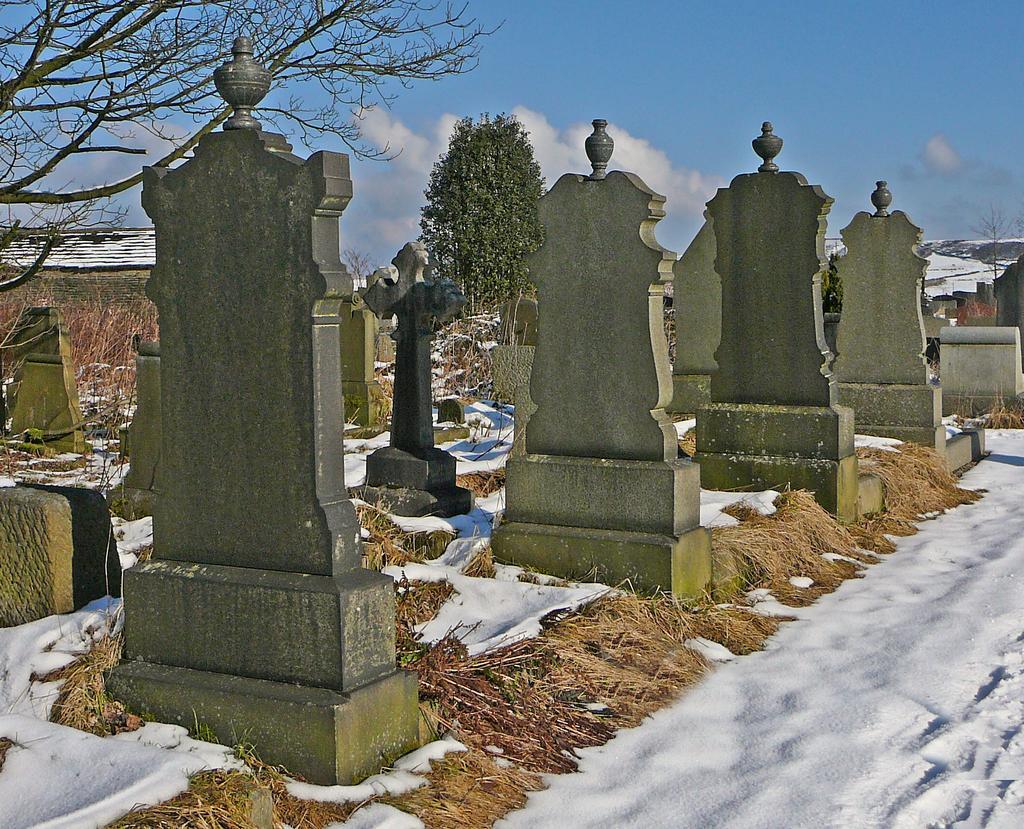In one or two sentences, can you explain what this image depicts? In the center of the image we can see graves, plants, trees, shed. At the bottom of the image we can see dry grass, snow. At the top of the image clouds are present in the sky. On the right side of the image mountains are there. 